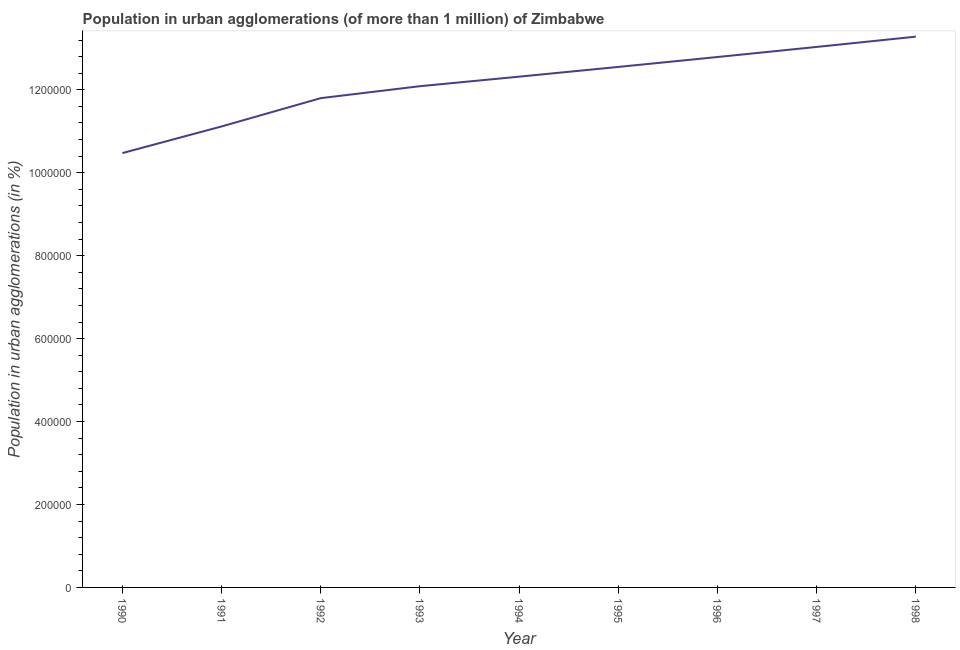What is the population in urban agglomerations in 1993?
Your response must be concise. 1.21e+06. Across all years, what is the maximum population in urban agglomerations?
Keep it short and to the point. 1.33e+06. Across all years, what is the minimum population in urban agglomerations?
Provide a short and direct response. 1.05e+06. In which year was the population in urban agglomerations maximum?
Your response must be concise. 1998. In which year was the population in urban agglomerations minimum?
Offer a very short reply. 1990. What is the sum of the population in urban agglomerations?
Keep it short and to the point. 1.09e+07. What is the difference between the population in urban agglomerations in 1993 and 1994?
Keep it short and to the point. -2.30e+04. What is the average population in urban agglomerations per year?
Your answer should be compact. 1.22e+06. What is the median population in urban agglomerations?
Ensure brevity in your answer.  1.23e+06. Do a majority of the years between 1995 and 1994 (inclusive) have population in urban agglomerations greater than 560000 %?
Ensure brevity in your answer.  No. What is the ratio of the population in urban agglomerations in 1991 to that in 1997?
Give a very brief answer. 0.85. Is the population in urban agglomerations in 1994 less than that in 1995?
Give a very brief answer. Yes. Is the difference between the population in urban agglomerations in 1990 and 1997 greater than the difference between any two years?
Offer a terse response. No. What is the difference between the highest and the second highest population in urban agglomerations?
Your response must be concise. 2.48e+04. What is the difference between the highest and the lowest population in urban agglomerations?
Ensure brevity in your answer.  2.81e+05. In how many years, is the population in urban agglomerations greater than the average population in urban agglomerations taken over all years?
Provide a succinct answer. 5. What is the difference between two consecutive major ticks on the Y-axis?
Keep it short and to the point. 2.00e+05. Does the graph contain any zero values?
Give a very brief answer. No. What is the title of the graph?
Offer a very short reply. Population in urban agglomerations (of more than 1 million) of Zimbabwe. What is the label or title of the X-axis?
Keep it short and to the point. Year. What is the label or title of the Y-axis?
Make the answer very short. Population in urban agglomerations (in %). What is the Population in urban agglomerations (in %) in 1990?
Your answer should be compact. 1.05e+06. What is the Population in urban agglomerations (in %) in 1991?
Ensure brevity in your answer.  1.11e+06. What is the Population in urban agglomerations (in %) in 1992?
Provide a succinct answer. 1.18e+06. What is the Population in urban agglomerations (in %) of 1993?
Offer a terse response. 1.21e+06. What is the Population in urban agglomerations (in %) in 1994?
Offer a terse response. 1.23e+06. What is the Population in urban agglomerations (in %) in 1995?
Offer a terse response. 1.26e+06. What is the Population in urban agglomerations (in %) in 1996?
Give a very brief answer. 1.28e+06. What is the Population in urban agglomerations (in %) in 1997?
Provide a succinct answer. 1.30e+06. What is the Population in urban agglomerations (in %) of 1998?
Ensure brevity in your answer.  1.33e+06. What is the difference between the Population in urban agglomerations (in %) in 1990 and 1991?
Provide a succinct answer. -6.42e+04. What is the difference between the Population in urban agglomerations (in %) in 1990 and 1992?
Your response must be concise. -1.32e+05. What is the difference between the Population in urban agglomerations (in %) in 1990 and 1993?
Offer a very short reply. -1.61e+05. What is the difference between the Population in urban agglomerations (in %) in 1990 and 1994?
Provide a succinct answer. -1.84e+05. What is the difference between the Population in urban agglomerations (in %) in 1990 and 1995?
Provide a succinct answer. -2.08e+05. What is the difference between the Population in urban agglomerations (in %) in 1990 and 1996?
Ensure brevity in your answer.  -2.32e+05. What is the difference between the Population in urban agglomerations (in %) in 1990 and 1997?
Keep it short and to the point. -2.56e+05. What is the difference between the Population in urban agglomerations (in %) in 1990 and 1998?
Ensure brevity in your answer.  -2.81e+05. What is the difference between the Population in urban agglomerations (in %) in 1991 and 1992?
Your answer should be very brief. -6.82e+04. What is the difference between the Population in urban agglomerations (in %) in 1991 and 1993?
Provide a succinct answer. -9.71e+04. What is the difference between the Population in urban agglomerations (in %) in 1991 and 1994?
Your response must be concise. -1.20e+05. What is the difference between the Population in urban agglomerations (in %) in 1991 and 1995?
Offer a terse response. -1.44e+05. What is the difference between the Population in urban agglomerations (in %) in 1991 and 1996?
Ensure brevity in your answer.  -1.67e+05. What is the difference between the Population in urban agglomerations (in %) in 1991 and 1997?
Keep it short and to the point. -1.92e+05. What is the difference between the Population in urban agglomerations (in %) in 1991 and 1998?
Ensure brevity in your answer.  -2.17e+05. What is the difference between the Population in urban agglomerations (in %) in 1992 and 1993?
Ensure brevity in your answer.  -2.88e+04. What is the difference between the Population in urban agglomerations (in %) in 1992 and 1994?
Your answer should be compact. -5.18e+04. What is the difference between the Population in urban agglomerations (in %) in 1992 and 1995?
Keep it short and to the point. -7.53e+04. What is the difference between the Population in urban agglomerations (in %) in 1992 and 1996?
Keep it short and to the point. -9.92e+04. What is the difference between the Population in urban agglomerations (in %) in 1992 and 1997?
Give a very brief answer. -1.24e+05. What is the difference between the Population in urban agglomerations (in %) in 1992 and 1998?
Give a very brief answer. -1.48e+05. What is the difference between the Population in urban agglomerations (in %) in 1993 and 1994?
Provide a short and direct response. -2.30e+04. What is the difference between the Population in urban agglomerations (in %) in 1993 and 1995?
Ensure brevity in your answer.  -4.64e+04. What is the difference between the Population in urban agglomerations (in %) in 1993 and 1996?
Offer a terse response. -7.04e+04. What is the difference between the Population in urban agglomerations (in %) in 1993 and 1997?
Your response must be concise. -9.47e+04. What is the difference between the Population in urban agglomerations (in %) in 1993 and 1998?
Your answer should be compact. -1.19e+05. What is the difference between the Population in urban agglomerations (in %) in 1994 and 1995?
Keep it short and to the point. -2.34e+04. What is the difference between the Population in urban agglomerations (in %) in 1994 and 1996?
Offer a very short reply. -4.74e+04. What is the difference between the Population in urban agglomerations (in %) in 1994 and 1997?
Give a very brief answer. -7.17e+04. What is the difference between the Population in urban agglomerations (in %) in 1994 and 1998?
Your answer should be very brief. -9.65e+04. What is the difference between the Population in urban agglomerations (in %) in 1995 and 1996?
Provide a short and direct response. -2.39e+04. What is the difference between the Population in urban agglomerations (in %) in 1995 and 1997?
Make the answer very short. -4.82e+04. What is the difference between the Population in urban agglomerations (in %) in 1995 and 1998?
Your response must be concise. -7.30e+04. What is the difference between the Population in urban agglomerations (in %) in 1996 and 1997?
Make the answer very short. -2.43e+04. What is the difference between the Population in urban agglomerations (in %) in 1996 and 1998?
Your response must be concise. -4.91e+04. What is the difference between the Population in urban agglomerations (in %) in 1997 and 1998?
Your answer should be compact. -2.48e+04. What is the ratio of the Population in urban agglomerations (in %) in 1990 to that in 1991?
Offer a very short reply. 0.94. What is the ratio of the Population in urban agglomerations (in %) in 1990 to that in 1992?
Offer a terse response. 0.89. What is the ratio of the Population in urban agglomerations (in %) in 1990 to that in 1993?
Give a very brief answer. 0.87. What is the ratio of the Population in urban agglomerations (in %) in 1990 to that in 1994?
Keep it short and to the point. 0.85. What is the ratio of the Population in urban agglomerations (in %) in 1990 to that in 1995?
Your answer should be compact. 0.83. What is the ratio of the Population in urban agglomerations (in %) in 1990 to that in 1996?
Offer a terse response. 0.82. What is the ratio of the Population in urban agglomerations (in %) in 1990 to that in 1997?
Offer a terse response. 0.8. What is the ratio of the Population in urban agglomerations (in %) in 1990 to that in 1998?
Make the answer very short. 0.79. What is the ratio of the Population in urban agglomerations (in %) in 1991 to that in 1992?
Provide a succinct answer. 0.94. What is the ratio of the Population in urban agglomerations (in %) in 1991 to that in 1994?
Offer a terse response. 0.9. What is the ratio of the Population in urban agglomerations (in %) in 1991 to that in 1995?
Provide a short and direct response. 0.89. What is the ratio of the Population in urban agglomerations (in %) in 1991 to that in 1996?
Make the answer very short. 0.87. What is the ratio of the Population in urban agglomerations (in %) in 1991 to that in 1997?
Your answer should be very brief. 0.85. What is the ratio of the Population in urban agglomerations (in %) in 1991 to that in 1998?
Provide a succinct answer. 0.84. What is the ratio of the Population in urban agglomerations (in %) in 1992 to that in 1994?
Provide a succinct answer. 0.96. What is the ratio of the Population in urban agglomerations (in %) in 1992 to that in 1996?
Provide a succinct answer. 0.92. What is the ratio of the Population in urban agglomerations (in %) in 1992 to that in 1997?
Ensure brevity in your answer.  0.91. What is the ratio of the Population in urban agglomerations (in %) in 1992 to that in 1998?
Provide a short and direct response. 0.89. What is the ratio of the Population in urban agglomerations (in %) in 1993 to that in 1994?
Provide a succinct answer. 0.98. What is the ratio of the Population in urban agglomerations (in %) in 1993 to that in 1996?
Provide a succinct answer. 0.94. What is the ratio of the Population in urban agglomerations (in %) in 1993 to that in 1997?
Make the answer very short. 0.93. What is the ratio of the Population in urban agglomerations (in %) in 1993 to that in 1998?
Keep it short and to the point. 0.91. What is the ratio of the Population in urban agglomerations (in %) in 1994 to that in 1996?
Offer a very short reply. 0.96. What is the ratio of the Population in urban agglomerations (in %) in 1994 to that in 1997?
Offer a terse response. 0.94. What is the ratio of the Population in urban agglomerations (in %) in 1994 to that in 1998?
Your answer should be compact. 0.93. What is the ratio of the Population in urban agglomerations (in %) in 1995 to that in 1997?
Your answer should be very brief. 0.96. What is the ratio of the Population in urban agglomerations (in %) in 1995 to that in 1998?
Make the answer very short. 0.94. 